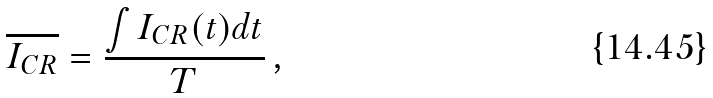<formula> <loc_0><loc_0><loc_500><loc_500>\overline { I _ { C R } } = \frac { \int I _ { C R } ( t ) d t } { T } \, ,</formula> 